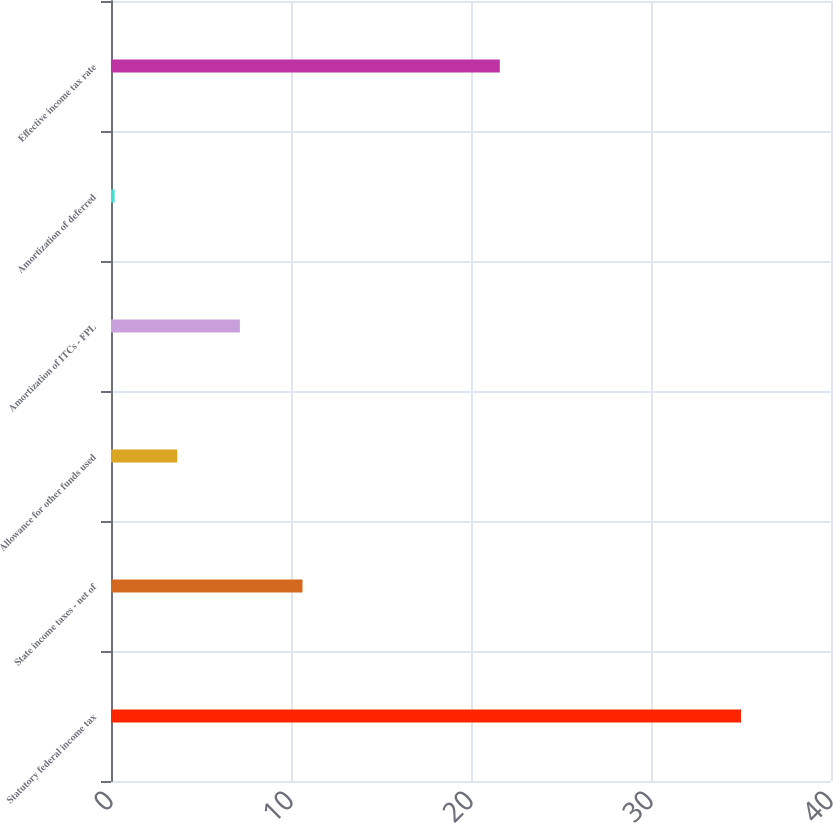Convert chart. <chart><loc_0><loc_0><loc_500><loc_500><bar_chart><fcel>Statutory federal income tax<fcel>State income taxes - net of<fcel>Allowance for other funds used<fcel>Amortization of ITCs - FPL<fcel>Amortization of deferred<fcel>Effective income tax rate<nl><fcel>35<fcel>10.64<fcel>3.68<fcel>7.16<fcel>0.2<fcel>21.6<nl></chart> 